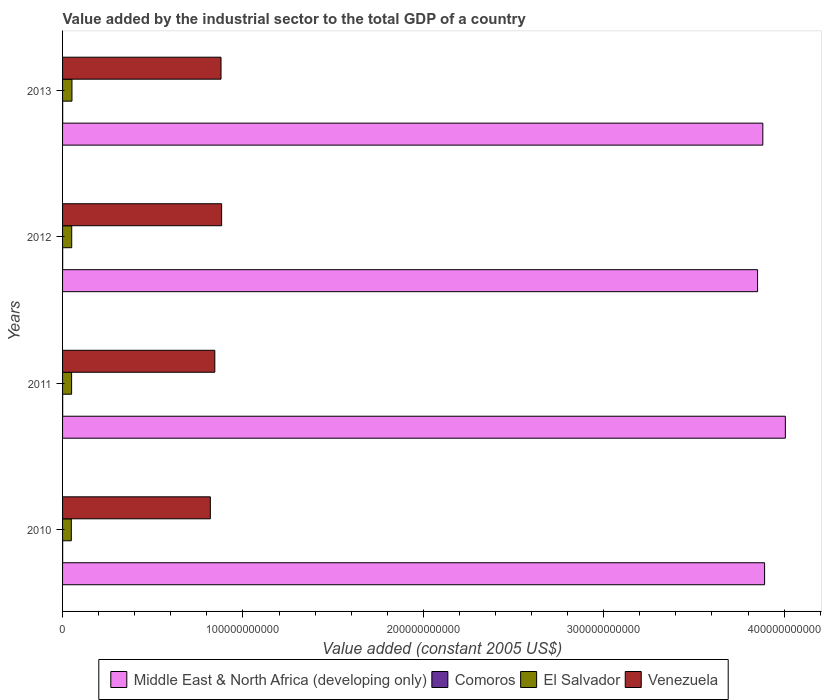How many groups of bars are there?
Offer a very short reply. 4. Are the number of bars on each tick of the Y-axis equal?
Give a very brief answer. Yes. How many bars are there on the 1st tick from the top?
Give a very brief answer. 4. How many bars are there on the 4th tick from the bottom?
Offer a terse response. 4. What is the label of the 1st group of bars from the top?
Offer a terse response. 2013. In how many cases, is the number of bars for a given year not equal to the number of legend labels?
Provide a succinct answer. 0. What is the value added by the industrial sector in Comoros in 2013?
Provide a short and direct response. 5.82e+07. Across all years, what is the maximum value added by the industrial sector in El Salvador?
Offer a terse response. 5.21e+09. Across all years, what is the minimum value added by the industrial sector in Venezuela?
Give a very brief answer. 8.19e+1. In which year was the value added by the industrial sector in Venezuela maximum?
Ensure brevity in your answer.  2012. What is the total value added by the industrial sector in Comoros in the graph?
Offer a terse response. 2.23e+08. What is the difference between the value added by the industrial sector in Middle East & North Africa (developing only) in 2010 and that in 2012?
Offer a very short reply. 3.89e+09. What is the difference between the value added by the industrial sector in El Salvador in 2011 and the value added by the industrial sector in Middle East & North Africa (developing only) in 2012?
Offer a very short reply. -3.80e+11. What is the average value added by the industrial sector in Venezuela per year?
Keep it short and to the point. 8.56e+1. In the year 2010, what is the difference between the value added by the industrial sector in Middle East & North Africa (developing only) and value added by the industrial sector in Venezuela?
Make the answer very short. 3.07e+11. What is the ratio of the value added by the industrial sector in El Salvador in 2012 to that in 2013?
Provide a succinct answer. 0.97. Is the value added by the industrial sector in Middle East & North Africa (developing only) in 2010 less than that in 2012?
Provide a short and direct response. No. Is the difference between the value added by the industrial sector in Middle East & North Africa (developing only) in 2012 and 2013 greater than the difference between the value added by the industrial sector in Venezuela in 2012 and 2013?
Your response must be concise. No. What is the difference between the highest and the second highest value added by the industrial sector in Venezuela?
Your answer should be very brief. 3.36e+08. What is the difference between the highest and the lowest value added by the industrial sector in Comoros?
Your answer should be very brief. 5.11e+06. What does the 3rd bar from the top in 2013 represents?
Provide a succinct answer. Comoros. What does the 4th bar from the bottom in 2011 represents?
Give a very brief answer. Venezuela. How many bars are there?
Make the answer very short. 16. Are all the bars in the graph horizontal?
Your answer should be very brief. Yes. What is the difference between two consecutive major ticks on the X-axis?
Your response must be concise. 1.00e+11. Are the values on the major ticks of X-axis written in scientific E-notation?
Offer a very short reply. No. Does the graph contain any zero values?
Ensure brevity in your answer.  No. Where does the legend appear in the graph?
Provide a short and direct response. Bottom center. How many legend labels are there?
Keep it short and to the point. 4. How are the legend labels stacked?
Offer a terse response. Horizontal. What is the title of the graph?
Your response must be concise. Value added by the industrial sector to the total GDP of a country. What is the label or title of the X-axis?
Your answer should be very brief. Value added (constant 2005 US$). What is the label or title of the Y-axis?
Offer a very short reply. Years. What is the Value added (constant 2005 US$) of Middle East & North Africa (developing only) in 2010?
Your answer should be compact. 3.89e+11. What is the Value added (constant 2005 US$) of Comoros in 2010?
Provide a succinct answer. 5.31e+07. What is the Value added (constant 2005 US$) of El Salvador in 2010?
Offer a terse response. 4.85e+09. What is the Value added (constant 2005 US$) of Venezuela in 2010?
Offer a terse response. 8.19e+1. What is the Value added (constant 2005 US$) of Middle East & North Africa (developing only) in 2011?
Provide a succinct answer. 4.01e+11. What is the Value added (constant 2005 US$) of Comoros in 2011?
Your answer should be very brief. 5.48e+07. What is the Value added (constant 2005 US$) in El Salvador in 2011?
Your response must be concise. 5.02e+09. What is the Value added (constant 2005 US$) of Venezuela in 2011?
Your answer should be compact. 8.44e+1. What is the Value added (constant 2005 US$) in Middle East & North Africa (developing only) in 2012?
Provide a short and direct response. 3.85e+11. What is the Value added (constant 2005 US$) of Comoros in 2012?
Make the answer very short. 5.65e+07. What is the Value added (constant 2005 US$) in El Salvador in 2012?
Make the answer very short. 5.08e+09. What is the Value added (constant 2005 US$) in Venezuela in 2012?
Your response must be concise. 8.82e+1. What is the Value added (constant 2005 US$) of Middle East & North Africa (developing only) in 2013?
Give a very brief answer. 3.88e+11. What is the Value added (constant 2005 US$) in Comoros in 2013?
Provide a short and direct response. 5.82e+07. What is the Value added (constant 2005 US$) of El Salvador in 2013?
Your response must be concise. 5.21e+09. What is the Value added (constant 2005 US$) of Venezuela in 2013?
Provide a short and direct response. 8.78e+1. Across all years, what is the maximum Value added (constant 2005 US$) in Middle East & North Africa (developing only)?
Ensure brevity in your answer.  4.01e+11. Across all years, what is the maximum Value added (constant 2005 US$) of Comoros?
Provide a succinct answer. 5.82e+07. Across all years, what is the maximum Value added (constant 2005 US$) in El Salvador?
Offer a very short reply. 5.21e+09. Across all years, what is the maximum Value added (constant 2005 US$) of Venezuela?
Provide a succinct answer. 8.82e+1. Across all years, what is the minimum Value added (constant 2005 US$) in Middle East & North Africa (developing only)?
Your answer should be compact. 3.85e+11. Across all years, what is the minimum Value added (constant 2005 US$) of Comoros?
Keep it short and to the point. 5.31e+07. Across all years, what is the minimum Value added (constant 2005 US$) in El Salvador?
Offer a terse response. 4.85e+09. Across all years, what is the minimum Value added (constant 2005 US$) in Venezuela?
Make the answer very short. 8.19e+1. What is the total Value added (constant 2005 US$) of Middle East & North Africa (developing only) in the graph?
Make the answer very short. 1.56e+12. What is the total Value added (constant 2005 US$) in Comoros in the graph?
Give a very brief answer. 2.23e+08. What is the total Value added (constant 2005 US$) in El Salvador in the graph?
Provide a short and direct response. 2.02e+1. What is the total Value added (constant 2005 US$) of Venezuela in the graph?
Your answer should be very brief. 3.42e+11. What is the difference between the Value added (constant 2005 US$) in Middle East & North Africa (developing only) in 2010 and that in 2011?
Offer a terse response. -1.15e+1. What is the difference between the Value added (constant 2005 US$) of Comoros in 2010 and that in 2011?
Your response must be concise. -1.64e+06. What is the difference between the Value added (constant 2005 US$) of El Salvador in 2010 and that in 2011?
Provide a succinct answer. -1.67e+08. What is the difference between the Value added (constant 2005 US$) of Venezuela in 2010 and that in 2011?
Provide a succinct answer. -2.48e+09. What is the difference between the Value added (constant 2005 US$) of Middle East & North Africa (developing only) in 2010 and that in 2012?
Your answer should be compact. 3.89e+09. What is the difference between the Value added (constant 2005 US$) of Comoros in 2010 and that in 2012?
Give a very brief answer. -3.35e+06. What is the difference between the Value added (constant 2005 US$) of El Salvador in 2010 and that in 2012?
Your answer should be compact. -2.25e+08. What is the difference between the Value added (constant 2005 US$) of Venezuela in 2010 and that in 2012?
Ensure brevity in your answer.  -6.25e+09. What is the difference between the Value added (constant 2005 US$) of Middle East & North Africa (developing only) in 2010 and that in 2013?
Offer a terse response. 9.86e+08. What is the difference between the Value added (constant 2005 US$) of Comoros in 2010 and that in 2013?
Your answer should be compact. -5.11e+06. What is the difference between the Value added (constant 2005 US$) of El Salvador in 2010 and that in 2013?
Make the answer very short. -3.62e+08. What is the difference between the Value added (constant 2005 US$) of Venezuela in 2010 and that in 2013?
Give a very brief answer. -5.91e+09. What is the difference between the Value added (constant 2005 US$) of Middle East & North Africa (developing only) in 2011 and that in 2012?
Keep it short and to the point. 1.54e+1. What is the difference between the Value added (constant 2005 US$) of Comoros in 2011 and that in 2012?
Give a very brief answer. -1.70e+06. What is the difference between the Value added (constant 2005 US$) in El Salvador in 2011 and that in 2012?
Offer a very short reply. -5.86e+07. What is the difference between the Value added (constant 2005 US$) in Venezuela in 2011 and that in 2012?
Give a very brief answer. -3.77e+09. What is the difference between the Value added (constant 2005 US$) of Middle East & North Africa (developing only) in 2011 and that in 2013?
Offer a very short reply. 1.25e+1. What is the difference between the Value added (constant 2005 US$) of Comoros in 2011 and that in 2013?
Your answer should be very brief. -3.46e+06. What is the difference between the Value added (constant 2005 US$) in El Salvador in 2011 and that in 2013?
Offer a terse response. -1.95e+08. What is the difference between the Value added (constant 2005 US$) of Venezuela in 2011 and that in 2013?
Ensure brevity in your answer.  -3.44e+09. What is the difference between the Value added (constant 2005 US$) of Middle East & North Africa (developing only) in 2012 and that in 2013?
Provide a succinct answer. -2.91e+09. What is the difference between the Value added (constant 2005 US$) in Comoros in 2012 and that in 2013?
Make the answer very short. -1.76e+06. What is the difference between the Value added (constant 2005 US$) of El Salvador in 2012 and that in 2013?
Your answer should be very brief. -1.36e+08. What is the difference between the Value added (constant 2005 US$) in Venezuela in 2012 and that in 2013?
Offer a very short reply. 3.36e+08. What is the difference between the Value added (constant 2005 US$) in Middle East & North Africa (developing only) in 2010 and the Value added (constant 2005 US$) in Comoros in 2011?
Offer a very short reply. 3.89e+11. What is the difference between the Value added (constant 2005 US$) of Middle East & North Africa (developing only) in 2010 and the Value added (constant 2005 US$) of El Salvador in 2011?
Give a very brief answer. 3.84e+11. What is the difference between the Value added (constant 2005 US$) of Middle East & North Africa (developing only) in 2010 and the Value added (constant 2005 US$) of Venezuela in 2011?
Your response must be concise. 3.05e+11. What is the difference between the Value added (constant 2005 US$) in Comoros in 2010 and the Value added (constant 2005 US$) in El Salvador in 2011?
Give a very brief answer. -4.96e+09. What is the difference between the Value added (constant 2005 US$) in Comoros in 2010 and the Value added (constant 2005 US$) in Venezuela in 2011?
Your answer should be very brief. -8.44e+1. What is the difference between the Value added (constant 2005 US$) of El Salvador in 2010 and the Value added (constant 2005 US$) of Venezuela in 2011?
Give a very brief answer. -7.96e+1. What is the difference between the Value added (constant 2005 US$) in Middle East & North Africa (developing only) in 2010 and the Value added (constant 2005 US$) in Comoros in 2012?
Offer a very short reply. 3.89e+11. What is the difference between the Value added (constant 2005 US$) in Middle East & North Africa (developing only) in 2010 and the Value added (constant 2005 US$) in El Salvador in 2012?
Provide a succinct answer. 3.84e+11. What is the difference between the Value added (constant 2005 US$) of Middle East & North Africa (developing only) in 2010 and the Value added (constant 2005 US$) of Venezuela in 2012?
Ensure brevity in your answer.  3.01e+11. What is the difference between the Value added (constant 2005 US$) of Comoros in 2010 and the Value added (constant 2005 US$) of El Salvador in 2012?
Your answer should be compact. -5.02e+09. What is the difference between the Value added (constant 2005 US$) in Comoros in 2010 and the Value added (constant 2005 US$) in Venezuela in 2012?
Keep it short and to the point. -8.81e+1. What is the difference between the Value added (constant 2005 US$) of El Salvador in 2010 and the Value added (constant 2005 US$) of Venezuela in 2012?
Keep it short and to the point. -8.33e+1. What is the difference between the Value added (constant 2005 US$) of Middle East & North Africa (developing only) in 2010 and the Value added (constant 2005 US$) of Comoros in 2013?
Provide a succinct answer. 3.89e+11. What is the difference between the Value added (constant 2005 US$) in Middle East & North Africa (developing only) in 2010 and the Value added (constant 2005 US$) in El Salvador in 2013?
Provide a succinct answer. 3.84e+11. What is the difference between the Value added (constant 2005 US$) of Middle East & North Africa (developing only) in 2010 and the Value added (constant 2005 US$) of Venezuela in 2013?
Make the answer very short. 3.01e+11. What is the difference between the Value added (constant 2005 US$) of Comoros in 2010 and the Value added (constant 2005 US$) of El Salvador in 2013?
Your answer should be compact. -5.16e+09. What is the difference between the Value added (constant 2005 US$) in Comoros in 2010 and the Value added (constant 2005 US$) in Venezuela in 2013?
Your answer should be compact. -8.78e+1. What is the difference between the Value added (constant 2005 US$) in El Salvador in 2010 and the Value added (constant 2005 US$) in Venezuela in 2013?
Your answer should be very brief. -8.30e+1. What is the difference between the Value added (constant 2005 US$) of Middle East & North Africa (developing only) in 2011 and the Value added (constant 2005 US$) of Comoros in 2012?
Make the answer very short. 4.01e+11. What is the difference between the Value added (constant 2005 US$) of Middle East & North Africa (developing only) in 2011 and the Value added (constant 2005 US$) of El Salvador in 2012?
Offer a very short reply. 3.96e+11. What is the difference between the Value added (constant 2005 US$) in Middle East & North Africa (developing only) in 2011 and the Value added (constant 2005 US$) in Venezuela in 2012?
Your answer should be very brief. 3.13e+11. What is the difference between the Value added (constant 2005 US$) in Comoros in 2011 and the Value added (constant 2005 US$) in El Salvador in 2012?
Keep it short and to the point. -5.02e+09. What is the difference between the Value added (constant 2005 US$) of Comoros in 2011 and the Value added (constant 2005 US$) of Venezuela in 2012?
Provide a succinct answer. -8.81e+1. What is the difference between the Value added (constant 2005 US$) in El Salvador in 2011 and the Value added (constant 2005 US$) in Venezuela in 2012?
Your response must be concise. -8.32e+1. What is the difference between the Value added (constant 2005 US$) of Middle East & North Africa (developing only) in 2011 and the Value added (constant 2005 US$) of Comoros in 2013?
Keep it short and to the point. 4.01e+11. What is the difference between the Value added (constant 2005 US$) in Middle East & North Africa (developing only) in 2011 and the Value added (constant 2005 US$) in El Salvador in 2013?
Make the answer very short. 3.95e+11. What is the difference between the Value added (constant 2005 US$) of Middle East & North Africa (developing only) in 2011 and the Value added (constant 2005 US$) of Venezuela in 2013?
Provide a succinct answer. 3.13e+11. What is the difference between the Value added (constant 2005 US$) of Comoros in 2011 and the Value added (constant 2005 US$) of El Salvador in 2013?
Offer a very short reply. -5.16e+09. What is the difference between the Value added (constant 2005 US$) in Comoros in 2011 and the Value added (constant 2005 US$) in Venezuela in 2013?
Ensure brevity in your answer.  -8.78e+1. What is the difference between the Value added (constant 2005 US$) in El Salvador in 2011 and the Value added (constant 2005 US$) in Venezuela in 2013?
Offer a terse response. -8.28e+1. What is the difference between the Value added (constant 2005 US$) in Middle East & North Africa (developing only) in 2012 and the Value added (constant 2005 US$) in Comoros in 2013?
Keep it short and to the point. 3.85e+11. What is the difference between the Value added (constant 2005 US$) in Middle East & North Africa (developing only) in 2012 and the Value added (constant 2005 US$) in El Salvador in 2013?
Your response must be concise. 3.80e+11. What is the difference between the Value added (constant 2005 US$) of Middle East & North Africa (developing only) in 2012 and the Value added (constant 2005 US$) of Venezuela in 2013?
Your answer should be compact. 2.97e+11. What is the difference between the Value added (constant 2005 US$) in Comoros in 2012 and the Value added (constant 2005 US$) in El Salvador in 2013?
Offer a terse response. -5.16e+09. What is the difference between the Value added (constant 2005 US$) in Comoros in 2012 and the Value added (constant 2005 US$) in Venezuela in 2013?
Provide a short and direct response. -8.78e+1. What is the difference between the Value added (constant 2005 US$) of El Salvador in 2012 and the Value added (constant 2005 US$) of Venezuela in 2013?
Ensure brevity in your answer.  -8.28e+1. What is the average Value added (constant 2005 US$) in Middle East & North Africa (developing only) per year?
Offer a very short reply. 3.91e+11. What is the average Value added (constant 2005 US$) in Comoros per year?
Make the answer very short. 5.57e+07. What is the average Value added (constant 2005 US$) of El Salvador per year?
Your response must be concise. 5.04e+09. What is the average Value added (constant 2005 US$) of Venezuela per year?
Provide a succinct answer. 8.56e+1. In the year 2010, what is the difference between the Value added (constant 2005 US$) of Middle East & North Africa (developing only) and Value added (constant 2005 US$) of Comoros?
Ensure brevity in your answer.  3.89e+11. In the year 2010, what is the difference between the Value added (constant 2005 US$) of Middle East & North Africa (developing only) and Value added (constant 2005 US$) of El Salvador?
Give a very brief answer. 3.84e+11. In the year 2010, what is the difference between the Value added (constant 2005 US$) in Middle East & North Africa (developing only) and Value added (constant 2005 US$) in Venezuela?
Provide a succinct answer. 3.07e+11. In the year 2010, what is the difference between the Value added (constant 2005 US$) of Comoros and Value added (constant 2005 US$) of El Salvador?
Your response must be concise. -4.80e+09. In the year 2010, what is the difference between the Value added (constant 2005 US$) in Comoros and Value added (constant 2005 US$) in Venezuela?
Your answer should be compact. -8.19e+1. In the year 2010, what is the difference between the Value added (constant 2005 US$) of El Salvador and Value added (constant 2005 US$) of Venezuela?
Offer a very short reply. -7.71e+1. In the year 2011, what is the difference between the Value added (constant 2005 US$) in Middle East & North Africa (developing only) and Value added (constant 2005 US$) in Comoros?
Keep it short and to the point. 4.01e+11. In the year 2011, what is the difference between the Value added (constant 2005 US$) in Middle East & North Africa (developing only) and Value added (constant 2005 US$) in El Salvador?
Your response must be concise. 3.96e+11. In the year 2011, what is the difference between the Value added (constant 2005 US$) in Middle East & North Africa (developing only) and Value added (constant 2005 US$) in Venezuela?
Keep it short and to the point. 3.16e+11. In the year 2011, what is the difference between the Value added (constant 2005 US$) in Comoros and Value added (constant 2005 US$) in El Salvador?
Give a very brief answer. -4.96e+09. In the year 2011, what is the difference between the Value added (constant 2005 US$) of Comoros and Value added (constant 2005 US$) of Venezuela?
Provide a succinct answer. -8.44e+1. In the year 2011, what is the difference between the Value added (constant 2005 US$) in El Salvador and Value added (constant 2005 US$) in Venezuela?
Provide a succinct answer. -7.94e+1. In the year 2012, what is the difference between the Value added (constant 2005 US$) of Middle East & North Africa (developing only) and Value added (constant 2005 US$) of Comoros?
Provide a succinct answer. 3.85e+11. In the year 2012, what is the difference between the Value added (constant 2005 US$) in Middle East & North Africa (developing only) and Value added (constant 2005 US$) in El Salvador?
Ensure brevity in your answer.  3.80e+11. In the year 2012, what is the difference between the Value added (constant 2005 US$) in Middle East & North Africa (developing only) and Value added (constant 2005 US$) in Venezuela?
Your answer should be compact. 2.97e+11. In the year 2012, what is the difference between the Value added (constant 2005 US$) of Comoros and Value added (constant 2005 US$) of El Salvador?
Ensure brevity in your answer.  -5.02e+09. In the year 2012, what is the difference between the Value added (constant 2005 US$) in Comoros and Value added (constant 2005 US$) in Venezuela?
Ensure brevity in your answer.  -8.81e+1. In the year 2012, what is the difference between the Value added (constant 2005 US$) in El Salvador and Value added (constant 2005 US$) in Venezuela?
Your answer should be compact. -8.31e+1. In the year 2013, what is the difference between the Value added (constant 2005 US$) in Middle East & North Africa (developing only) and Value added (constant 2005 US$) in Comoros?
Keep it short and to the point. 3.88e+11. In the year 2013, what is the difference between the Value added (constant 2005 US$) in Middle East & North Africa (developing only) and Value added (constant 2005 US$) in El Salvador?
Offer a very short reply. 3.83e+11. In the year 2013, what is the difference between the Value added (constant 2005 US$) of Middle East & North Africa (developing only) and Value added (constant 2005 US$) of Venezuela?
Your answer should be very brief. 3.00e+11. In the year 2013, what is the difference between the Value added (constant 2005 US$) in Comoros and Value added (constant 2005 US$) in El Salvador?
Offer a terse response. -5.15e+09. In the year 2013, what is the difference between the Value added (constant 2005 US$) of Comoros and Value added (constant 2005 US$) of Venezuela?
Ensure brevity in your answer.  -8.78e+1. In the year 2013, what is the difference between the Value added (constant 2005 US$) of El Salvador and Value added (constant 2005 US$) of Venezuela?
Your answer should be compact. -8.26e+1. What is the ratio of the Value added (constant 2005 US$) in Middle East & North Africa (developing only) in 2010 to that in 2011?
Offer a terse response. 0.97. What is the ratio of the Value added (constant 2005 US$) of Comoros in 2010 to that in 2011?
Offer a terse response. 0.97. What is the ratio of the Value added (constant 2005 US$) in El Salvador in 2010 to that in 2011?
Provide a succinct answer. 0.97. What is the ratio of the Value added (constant 2005 US$) of Venezuela in 2010 to that in 2011?
Your answer should be compact. 0.97. What is the ratio of the Value added (constant 2005 US$) in Middle East & North Africa (developing only) in 2010 to that in 2012?
Offer a terse response. 1.01. What is the ratio of the Value added (constant 2005 US$) of Comoros in 2010 to that in 2012?
Give a very brief answer. 0.94. What is the ratio of the Value added (constant 2005 US$) in El Salvador in 2010 to that in 2012?
Your response must be concise. 0.96. What is the ratio of the Value added (constant 2005 US$) of Venezuela in 2010 to that in 2012?
Provide a short and direct response. 0.93. What is the ratio of the Value added (constant 2005 US$) in Comoros in 2010 to that in 2013?
Provide a short and direct response. 0.91. What is the ratio of the Value added (constant 2005 US$) of El Salvador in 2010 to that in 2013?
Give a very brief answer. 0.93. What is the ratio of the Value added (constant 2005 US$) in Venezuela in 2010 to that in 2013?
Keep it short and to the point. 0.93. What is the ratio of the Value added (constant 2005 US$) in Middle East & North Africa (developing only) in 2011 to that in 2012?
Make the answer very short. 1.04. What is the ratio of the Value added (constant 2005 US$) in Comoros in 2011 to that in 2012?
Your response must be concise. 0.97. What is the ratio of the Value added (constant 2005 US$) in El Salvador in 2011 to that in 2012?
Keep it short and to the point. 0.99. What is the ratio of the Value added (constant 2005 US$) in Venezuela in 2011 to that in 2012?
Keep it short and to the point. 0.96. What is the ratio of the Value added (constant 2005 US$) in Middle East & North Africa (developing only) in 2011 to that in 2013?
Ensure brevity in your answer.  1.03. What is the ratio of the Value added (constant 2005 US$) of Comoros in 2011 to that in 2013?
Provide a succinct answer. 0.94. What is the ratio of the Value added (constant 2005 US$) in El Salvador in 2011 to that in 2013?
Your response must be concise. 0.96. What is the ratio of the Value added (constant 2005 US$) of Venezuela in 2011 to that in 2013?
Offer a terse response. 0.96. What is the ratio of the Value added (constant 2005 US$) in Middle East & North Africa (developing only) in 2012 to that in 2013?
Ensure brevity in your answer.  0.99. What is the ratio of the Value added (constant 2005 US$) in Comoros in 2012 to that in 2013?
Keep it short and to the point. 0.97. What is the ratio of the Value added (constant 2005 US$) of El Salvador in 2012 to that in 2013?
Offer a very short reply. 0.97. What is the difference between the highest and the second highest Value added (constant 2005 US$) in Middle East & North Africa (developing only)?
Your answer should be very brief. 1.15e+1. What is the difference between the highest and the second highest Value added (constant 2005 US$) of Comoros?
Ensure brevity in your answer.  1.76e+06. What is the difference between the highest and the second highest Value added (constant 2005 US$) in El Salvador?
Make the answer very short. 1.36e+08. What is the difference between the highest and the second highest Value added (constant 2005 US$) in Venezuela?
Make the answer very short. 3.36e+08. What is the difference between the highest and the lowest Value added (constant 2005 US$) of Middle East & North Africa (developing only)?
Ensure brevity in your answer.  1.54e+1. What is the difference between the highest and the lowest Value added (constant 2005 US$) of Comoros?
Provide a succinct answer. 5.11e+06. What is the difference between the highest and the lowest Value added (constant 2005 US$) in El Salvador?
Ensure brevity in your answer.  3.62e+08. What is the difference between the highest and the lowest Value added (constant 2005 US$) in Venezuela?
Ensure brevity in your answer.  6.25e+09. 